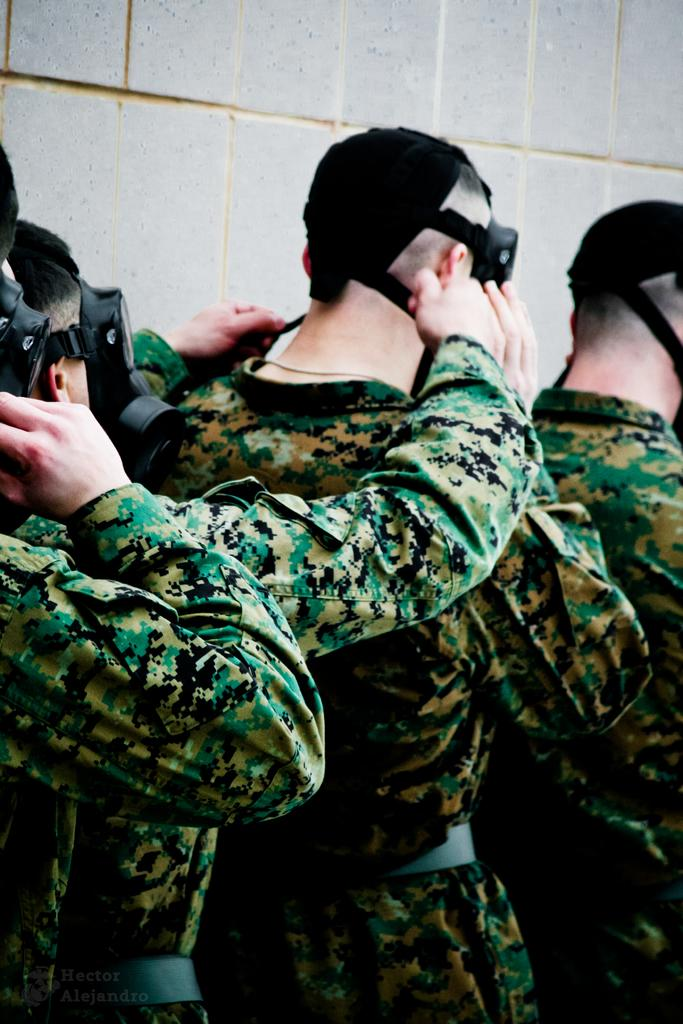What is the main subject in the foreground of the image? There is a group of people in the foreground of the image. What are the people wearing? The people are wearing uniforms. What else can be seen in the foreground of the image besides the group of people? There are other objects in the foreground of the image. What is visible in the background of the image? There is a wall in the background of the image. What year is depicted in the image? There is no specific year depicted in the image; it is a static scene. What division of the organization do the people in the image belong to? There is no information about the organization or division in the image. 